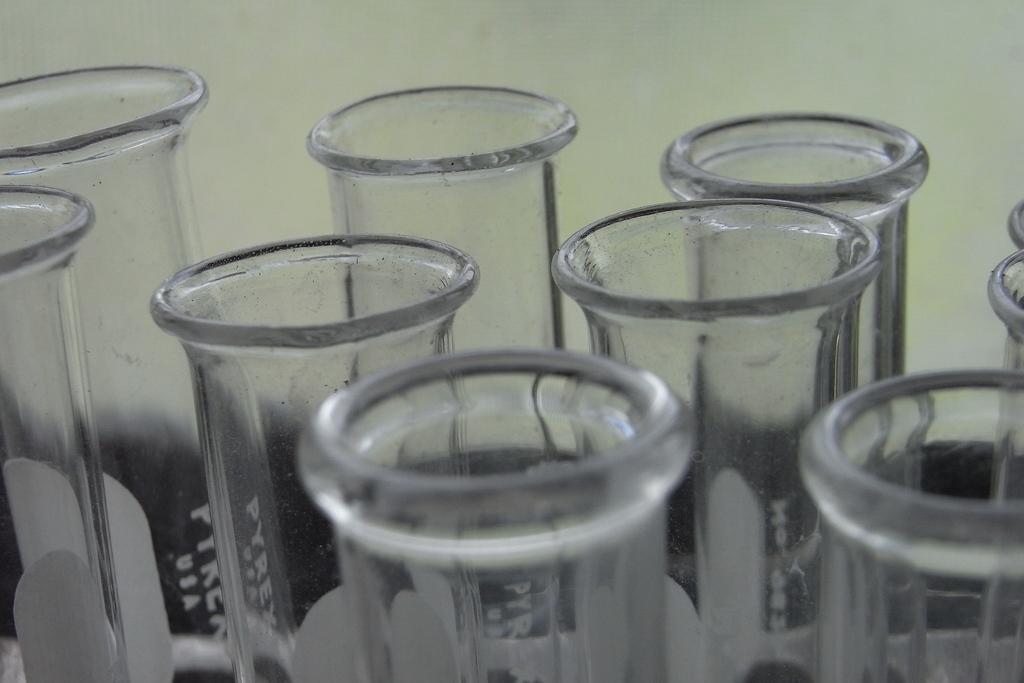Could you give a brief overview of what you see in this image? In this image I can see few glasses. In the background there is a wall. 